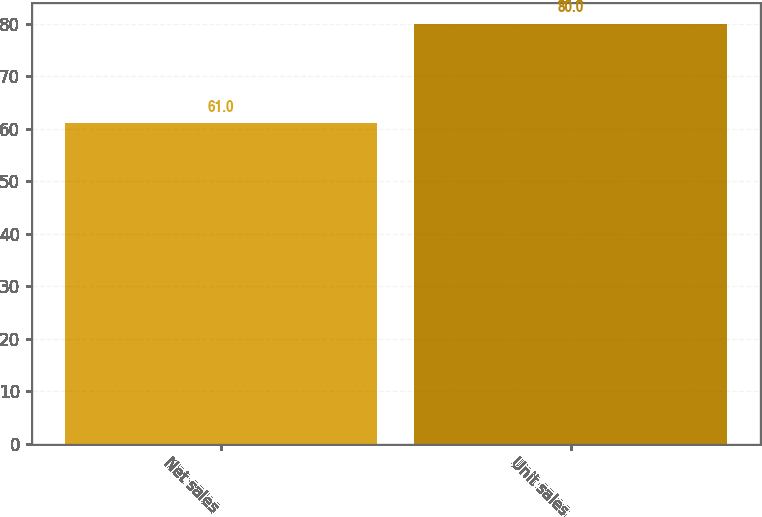Convert chart. <chart><loc_0><loc_0><loc_500><loc_500><bar_chart><fcel>Net sales<fcel>Unit sales<nl><fcel>61<fcel>80<nl></chart> 